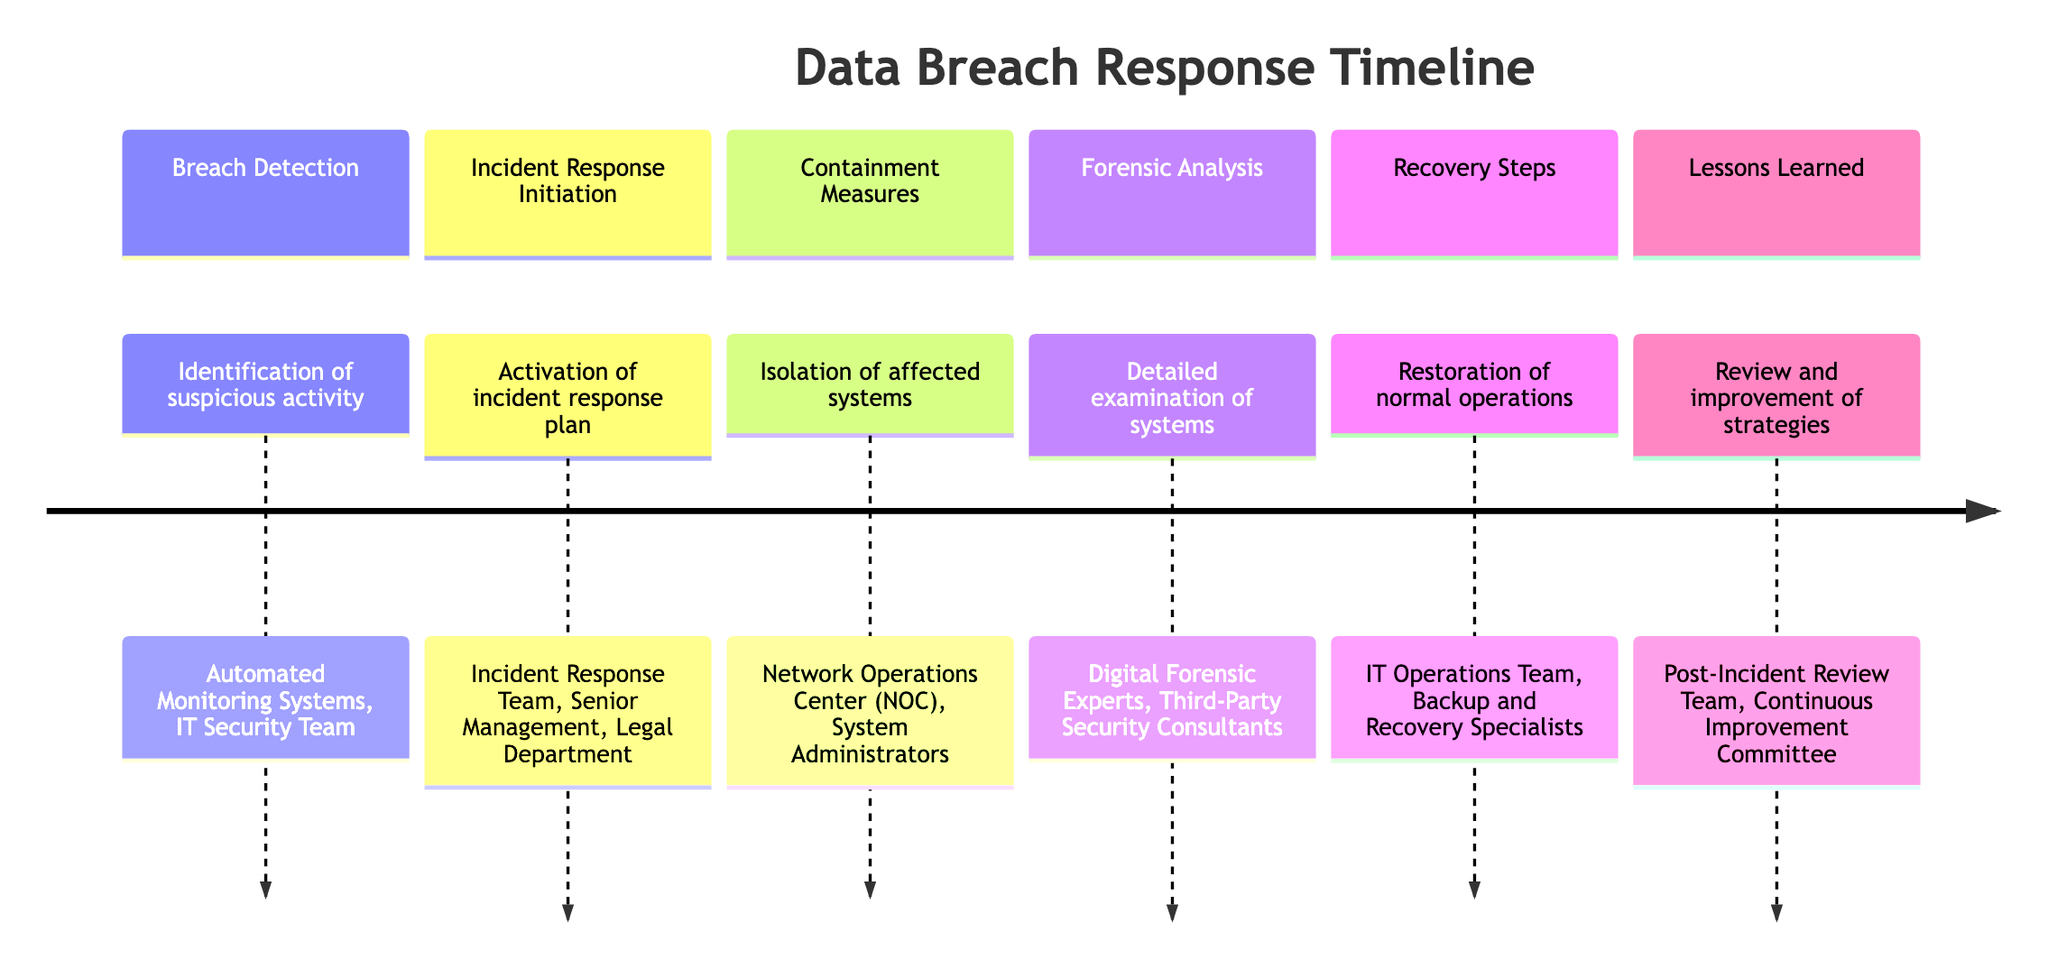What is the first stage of the data breach response timeline? The first stage listed is "Breach Detection," which focuses on identifying suspicious activity. It is the initial action taken when a potential data breach is suspected.
Answer: Breach Detection Which entities are involved in the containment measures? The entities mentioned during the containment measures include the Network Operations Center (NOC) and System Administrators, which are responsible for isolating the affected systems.
Answer: Network Operations Center (NOC), System Administrators How many stages are outlined in the timeline? Counting all the stages listed in the timeline, there are six distinct stages described, from "Breach Detection" to "Lessons Learned."
Answer: 6 What is the main goal of the forensic analysis stage? The forensic analysis stage aims for a detailed examination of the affected systems to understand the scope and origin of the breach. This indicates the effort to investigate what happened.
Answer: Detailed examination of affected systems Which team is responsible for activating the incident response plan? The "Incident Response Team" is identified as the key entity responsible for activating the incident response plan and notifying stakeholders once a breach is detected.
Answer: Incident Response Team In what stage do recovery steps take place? Recovery steps take place after the forensic analysis and are focused on restoring normal operations while ensuring vulnerabilities are addressed. This indicates it follows several earlier stages.
Answer: Recovery Steps Which group is tasked with reviewing the incident for lessons learned? The "Post-Incident Review Team" is responsible for reviewing the incident and identifying lessons to enhance future strategies, showing an emphasis on learning from past breaches.
Answer: Post-Incident Review Team What are the two main tasks during the "Containment Measures" stage? The main tasks during containment measures consist of isolating the affected systems and preventing further damage, focusing on immediate action to limit impact.
Answer: Actions taken to isolate affected systems Which entities are involved in the recovery steps? In the recovery steps, the involved entities are the IT Operations Team and Backup and Recovery Specialists, who work together to restore normal operations.
Answer: IT Operations Team, Backup and Recovery Specialists 